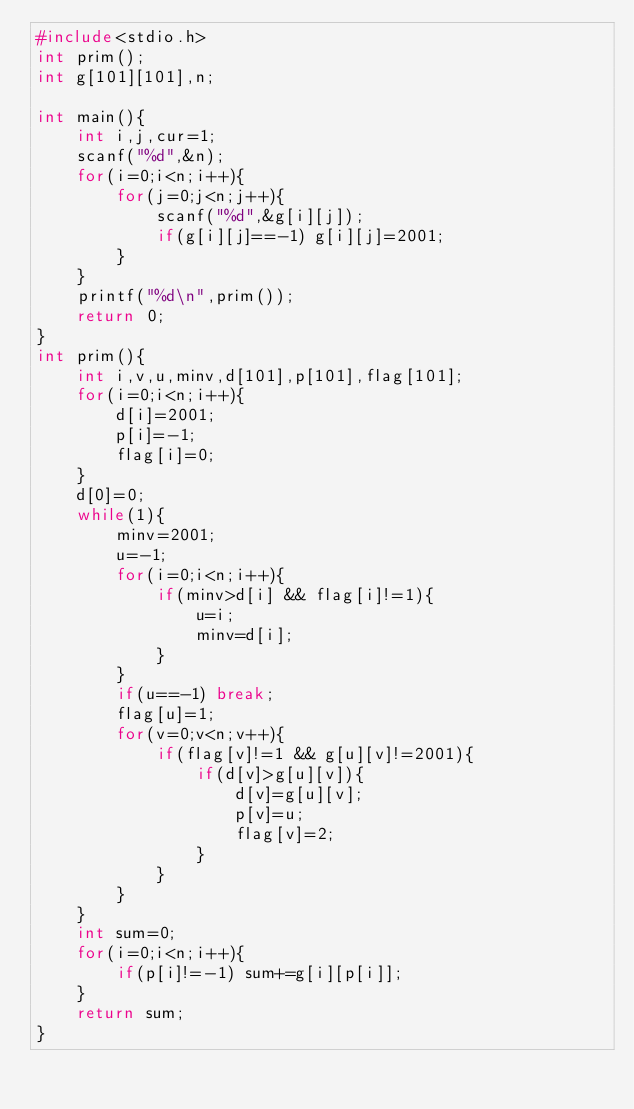<code> <loc_0><loc_0><loc_500><loc_500><_C_>#include<stdio.h>
int prim();
int g[101][101],n;

int main(){
    int i,j,cur=1;
    scanf("%d",&n);
    for(i=0;i<n;i++){
        for(j=0;j<n;j++){
            scanf("%d",&g[i][j]);
            if(g[i][j]==-1) g[i][j]=2001;
        }
    }
    printf("%d\n",prim());
    return 0;
}
int prim(){
    int i,v,u,minv,d[101],p[101],flag[101];
    for(i=0;i<n;i++){
        d[i]=2001;
        p[i]=-1;
        flag[i]=0;
    }
    d[0]=0;
    while(1){
        minv=2001;
        u=-1;
        for(i=0;i<n;i++){
            if(minv>d[i] && flag[i]!=1){
                u=i;
                minv=d[i];
            }
        }
        if(u==-1) break;
        flag[u]=1;
        for(v=0;v<n;v++){
            if(flag[v]!=1 && g[u][v]!=2001){
                if(d[v]>g[u][v]){
                    d[v]=g[u][v];
                    p[v]=u;
                    flag[v]=2;
                }
            }
        }
    }
    int sum=0;
    for(i=0;i<n;i++){
        if(p[i]!=-1) sum+=g[i][p[i]];
    }
    return sum;
}
</code> 